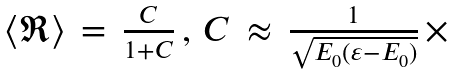<formula> <loc_0><loc_0><loc_500><loc_500>\begin{array} { c } \langle \Re \rangle \, = \, \frac { C } { 1 + C } \, , \, C \, \approx \, \frac { 1 } { \sqrt { E _ { 0 } ( \varepsilon - E _ { 0 } ) } } \, \times \, \end{array}</formula> 